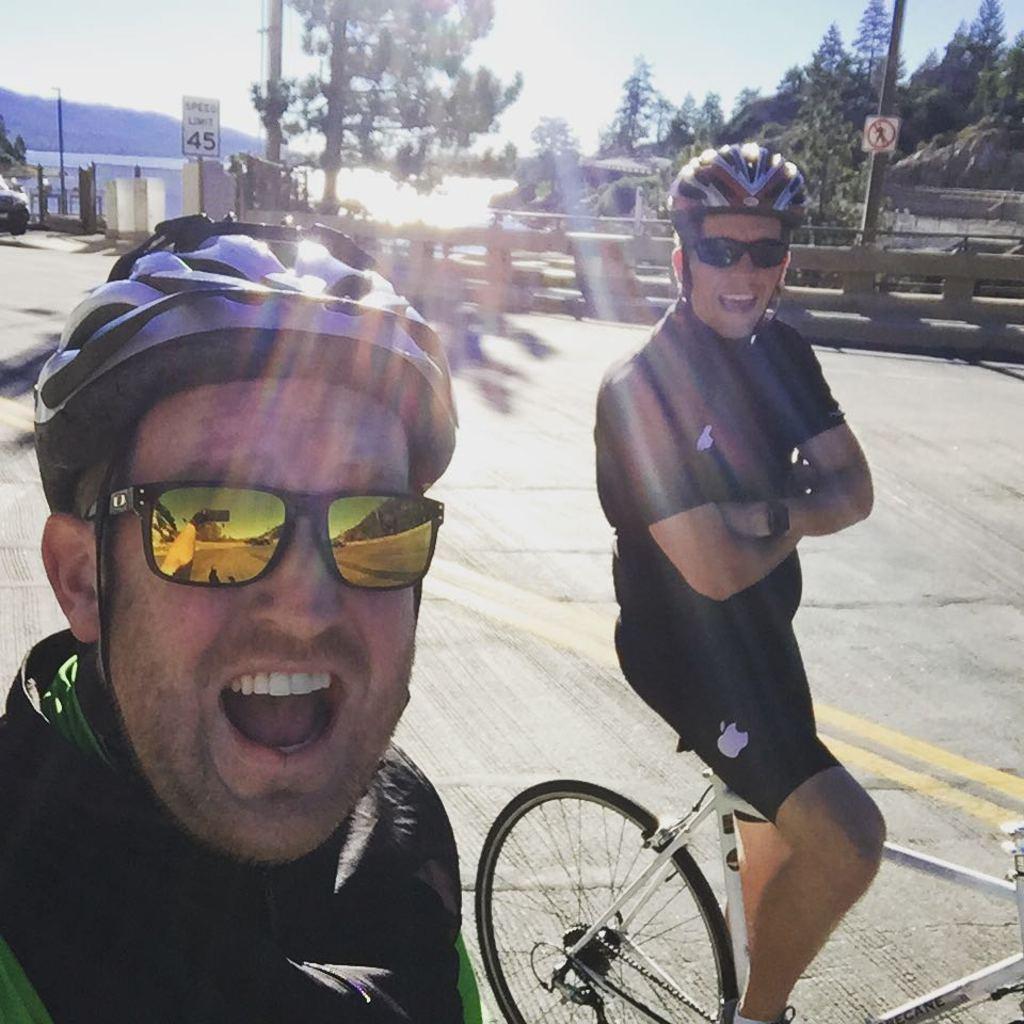Describe this image in one or two sentences. In this picture there are two persons those who are riding the bicycle and its a day time, there are some trees around the area of the image and the place where they are standing is area of the bridge. 